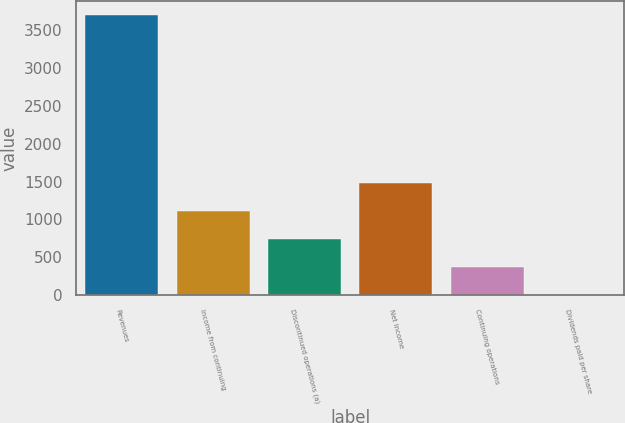Convert chart. <chart><loc_0><loc_0><loc_500><loc_500><bar_chart><fcel>Revenues<fcel>Income from continuing<fcel>Discontinued operations (a)<fcel>Net income<fcel>Continuing operations<fcel>Dividends paid per share<nl><fcel>3699<fcel>1109.83<fcel>739.95<fcel>1479.71<fcel>370.07<fcel>0.19<nl></chart> 